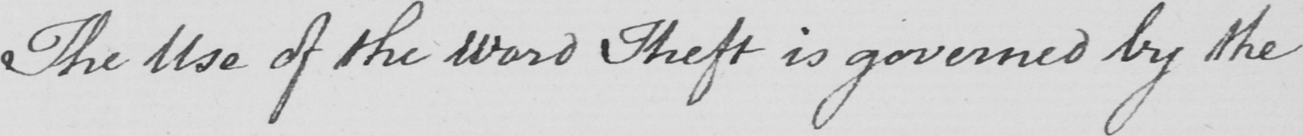What does this handwritten line say? The Use of the Word Theft is governed by the 